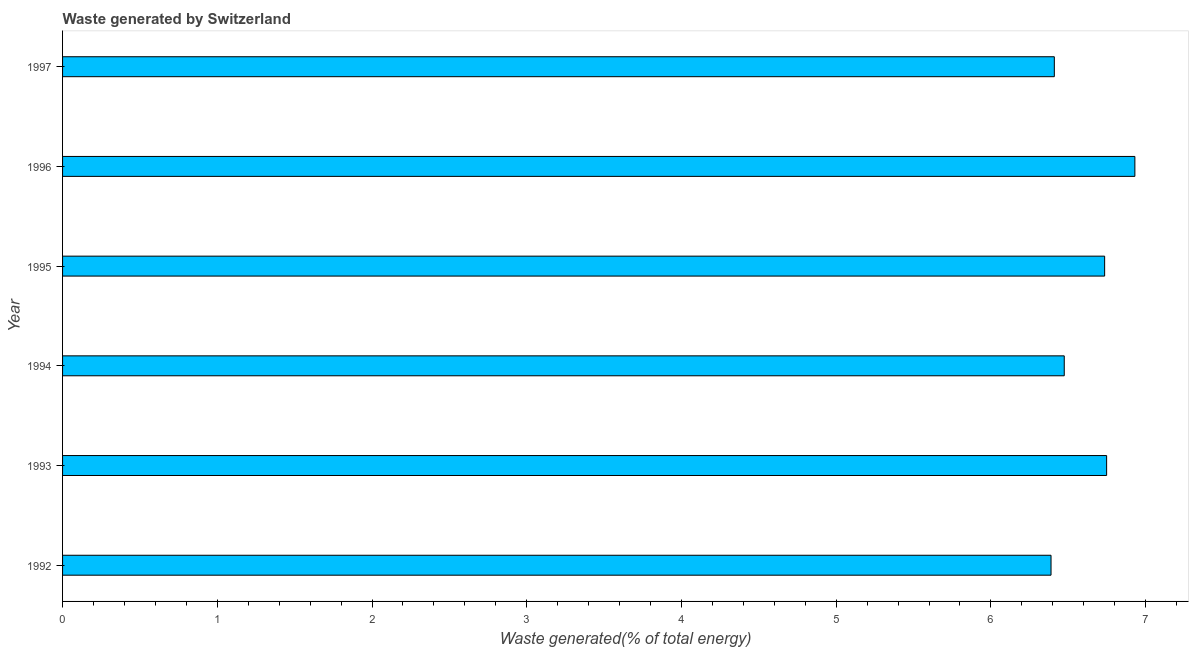What is the title of the graph?
Your answer should be compact. Waste generated by Switzerland. What is the label or title of the X-axis?
Your answer should be compact. Waste generated(% of total energy). What is the amount of waste generated in 1993?
Offer a terse response. 6.75. Across all years, what is the maximum amount of waste generated?
Provide a short and direct response. 6.93. Across all years, what is the minimum amount of waste generated?
Keep it short and to the point. 6.39. What is the sum of the amount of waste generated?
Make the answer very short. 39.69. What is the difference between the amount of waste generated in 1992 and 1993?
Ensure brevity in your answer.  -0.36. What is the average amount of waste generated per year?
Offer a very short reply. 6.61. What is the median amount of waste generated?
Provide a short and direct response. 6.6. In how many years, is the amount of waste generated greater than 3.8 %?
Your response must be concise. 6. What is the ratio of the amount of waste generated in 1995 to that in 1997?
Ensure brevity in your answer.  1.05. Is the amount of waste generated in 1993 less than that in 1996?
Give a very brief answer. Yes. Is the difference between the amount of waste generated in 1995 and 1996 greater than the difference between any two years?
Your response must be concise. No. What is the difference between the highest and the second highest amount of waste generated?
Keep it short and to the point. 0.18. What is the difference between the highest and the lowest amount of waste generated?
Offer a very short reply. 0.54. Are all the bars in the graph horizontal?
Provide a succinct answer. Yes. How many years are there in the graph?
Provide a succinct answer. 6. What is the Waste generated(% of total energy) in 1992?
Provide a short and direct response. 6.39. What is the Waste generated(% of total energy) of 1993?
Your answer should be compact. 6.75. What is the Waste generated(% of total energy) in 1994?
Make the answer very short. 6.47. What is the Waste generated(% of total energy) in 1995?
Give a very brief answer. 6.73. What is the Waste generated(% of total energy) of 1996?
Make the answer very short. 6.93. What is the Waste generated(% of total energy) of 1997?
Keep it short and to the point. 6.41. What is the difference between the Waste generated(% of total energy) in 1992 and 1993?
Your answer should be very brief. -0.36. What is the difference between the Waste generated(% of total energy) in 1992 and 1994?
Your answer should be very brief. -0.09. What is the difference between the Waste generated(% of total energy) in 1992 and 1995?
Your answer should be compact. -0.35. What is the difference between the Waste generated(% of total energy) in 1992 and 1996?
Offer a terse response. -0.54. What is the difference between the Waste generated(% of total energy) in 1992 and 1997?
Offer a terse response. -0.02. What is the difference between the Waste generated(% of total energy) in 1993 and 1994?
Your answer should be compact. 0.27. What is the difference between the Waste generated(% of total energy) in 1993 and 1995?
Ensure brevity in your answer.  0.01. What is the difference between the Waste generated(% of total energy) in 1993 and 1996?
Your answer should be compact. -0.18. What is the difference between the Waste generated(% of total energy) in 1993 and 1997?
Provide a short and direct response. 0.34. What is the difference between the Waste generated(% of total energy) in 1994 and 1995?
Provide a short and direct response. -0.26. What is the difference between the Waste generated(% of total energy) in 1994 and 1996?
Ensure brevity in your answer.  -0.46. What is the difference between the Waste generated(% of total energy) in 1994 and 1997?
Provide a short and direct response. 0.06. What is the difference between the Waste generated(% of total energy) in 1995 and 1996?
Give a very brief answer. -0.2. What is the difference between the Waste generated(% of total energy) in 1995 and 1997?
Make the answer very short. 0.33. What is the difference between the Waste generated(% of total energy) in 1996 and 1997?
Your answer should be very brief. 0.52. What is the ratio of the Waste generated(% of total energy) in 1992 to that in 1993?
Offer a very short reply. 0.95. What is the ratio of the Waste generated(% of total energy) in 1992 to that in 1994?
Provide a short and direct response. 0.99. What is the ratio of the Waste generated(% of total energy) in 1992 to that in 1995?
Make the answer very short. 0.95. What is the ratio of the Waste generated(% of total energy) in 1992 to that in 1996?
Keep it short and to the point. 0.92. What is the ratio of the Waste generated(% of total energy) in 1992 to that in 1997?
Offer a very short reply. 1. What is the ratio of the Waste generated(% of total energy) in 1993 to that in 1994?
Offer a terse response. 1.04. What is the ratio of the Waste generated(% of total energy) in 1993 to that in 1997?
Make the answer very short. 1.05. What is the ratio of the Waste generated(% of total energy) in 1994 to that in 1995?
Offer a terse response. 0.96. What is the ratio of the Waste generated(% of total energy) in 1994 to that in 1996?
Your answer should be compact. 0.93. What is the ratio of the Waste generated(% of total energy) in 1994 to that in 1997?
Ensure brevity in your answer.  1.01. What is the ratio of the Waste generated(% of total energy) in 1995 to that in 1997?
Your answer should be very brief. 1.05. What is the ratio of the Waste generated(% of total energy) in 1996 to that in 1997?
Ensure brevity in your answer.  1.08. 